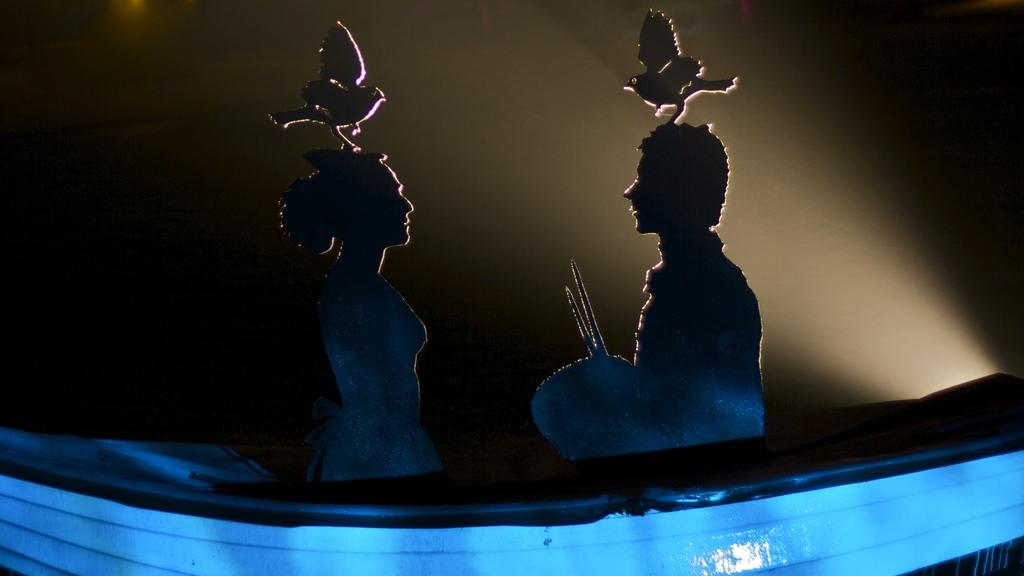What types of objects are depicted in the image? There are objects in the shape of people and objects in the shape of birds in the image. What color is one of the objects in the image? There is a blue color object in the image. How would you describe the background of the image? The background of the image is dark. What type of calendar is hanging on the wall in the image? There is no calendar present in the image. What kind of thrill can be experienced by the birds in the image? The image does not depict any birds experiencing a thrill, as they are inanimate objects. Can you tell me how many hens are visible in the image? There are no hens present in the image; it features objects in the shape of birds, but they are not specifically hens. 